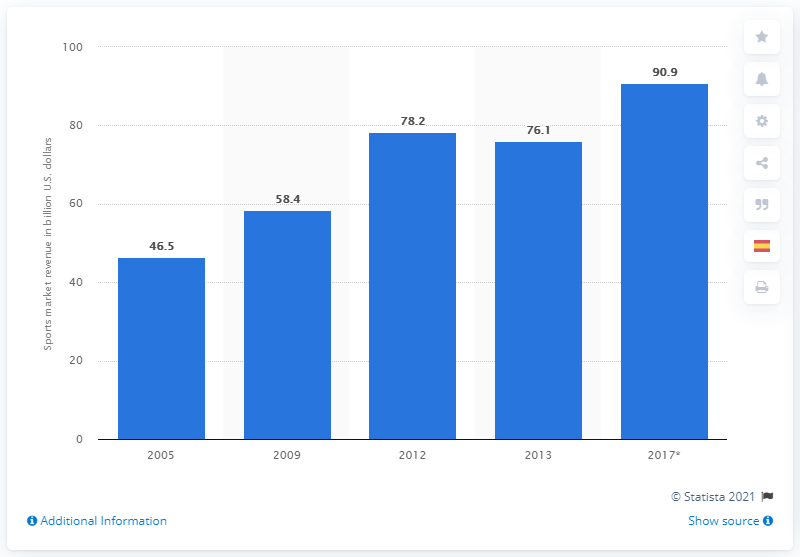Give some essential details in this illustration. According to estimates, the global sports market was projected to generate revenue of approximately 90.9 billion US dollars by 2017. 